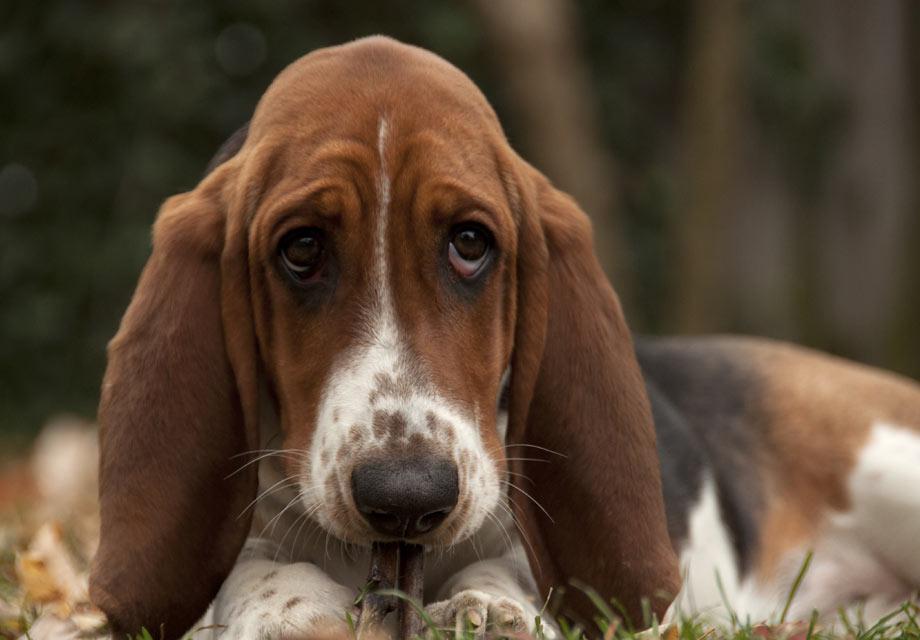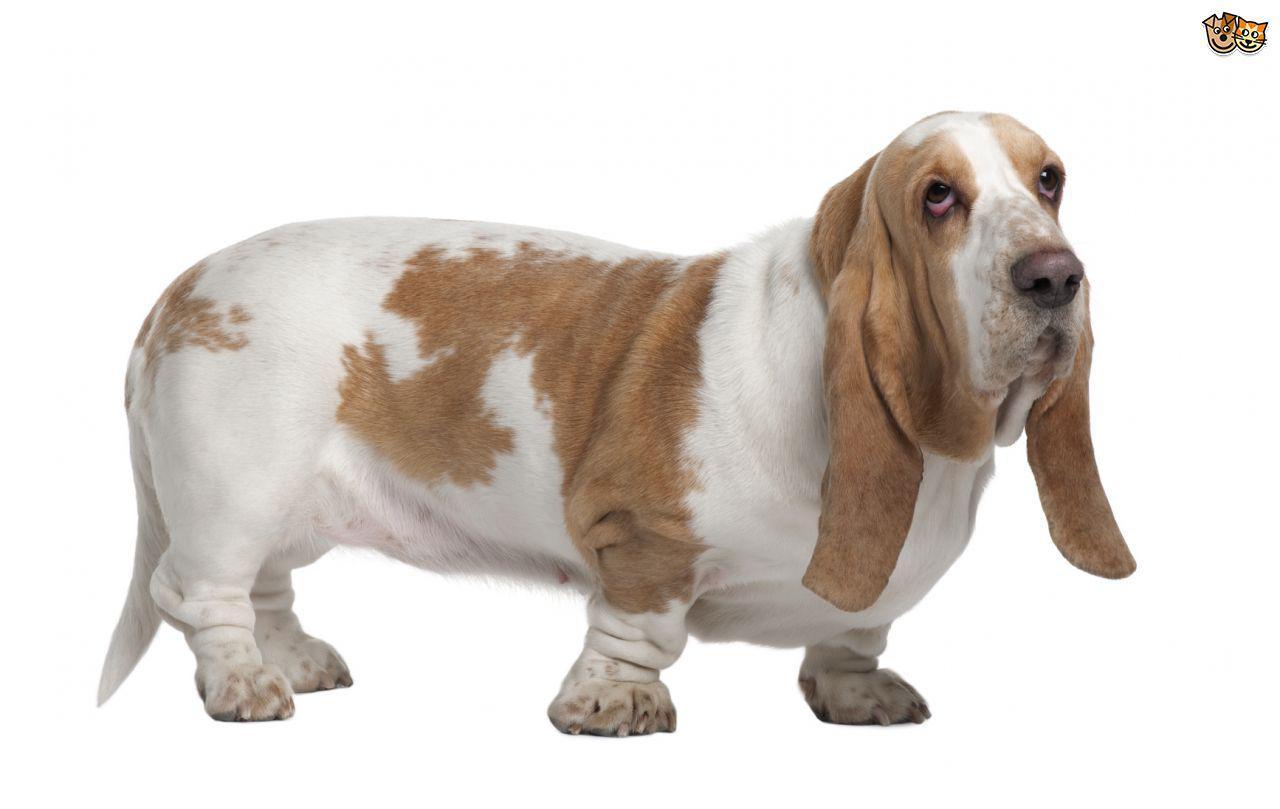The first image is the image on the left, the second image is the image on the right. Evaluate the accuracy of this statement regarding the images: "There are at least three dogs outside in the grass.". Is it true? Answer yes or no. No. The first image is the image on the left, the second image is the image on the right. For the images displayed, is the sentence "An image shows at least one camera-facing basset hound sitting upright in the grass." factually correct? Answer yes or no. No. 